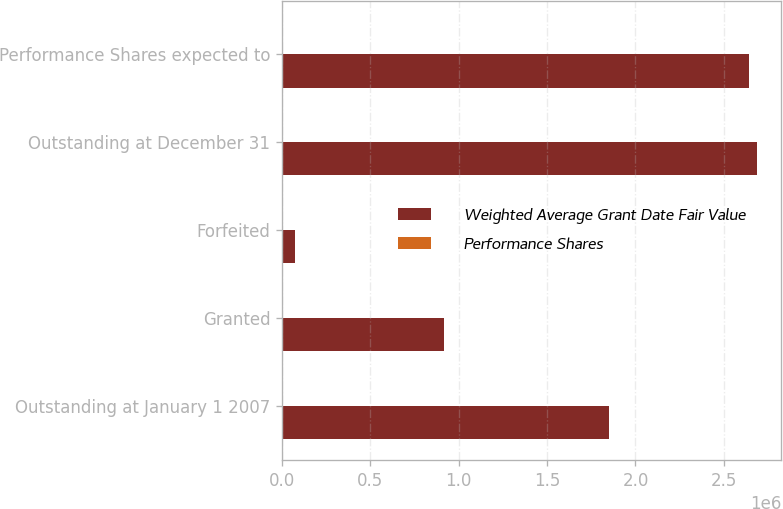<chart> <loc_0><loc_0><loc_500><loc_500><stacked_bar_chart><ecel><fcel>Outstanding at January 1 2007<fcel>Granted<fcel>Forfeited<fcel>Outstanding at December 31<fcel>Performance Shares expected to<nl><fcel>Weighted Average Grant Date Fair Value<fcel>1.84958e+06<fcel>916075<fcel>75525<fcel>2.69012e+06<fcel>2.64167e+06<nl><fcel>Performance Shares<fcel>42.24<fcel>60.86<fcel>49.2<fcel>48.39<fcel>48.2<nl></chart> 